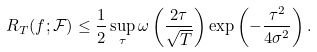<formula> <loc_0><loc_0><loc_500><loc_500>R _ { T } ( f ; \mathcal { F } ) \leq \frac { 1 } { 2 } \sup _ { \tau } \omega \left ( \frac { 2 \tau } { \sqrt { T } } \right ) \exp \left ( - \frac { \tau ^ { 2 } } { 4 \sigma ^ { 2 } } \right ) .</formula> 